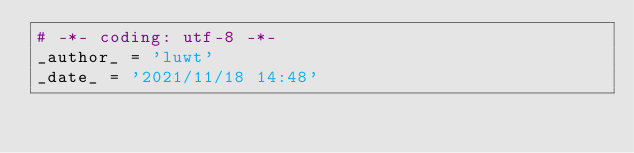<code> <loc_0><loc_0><loc_500><loc_500><_Python_># -*- coding: utf-8 -*-
_author_ = 'luwt'
_date_ = '2021/11/18 14:48'
</code> 